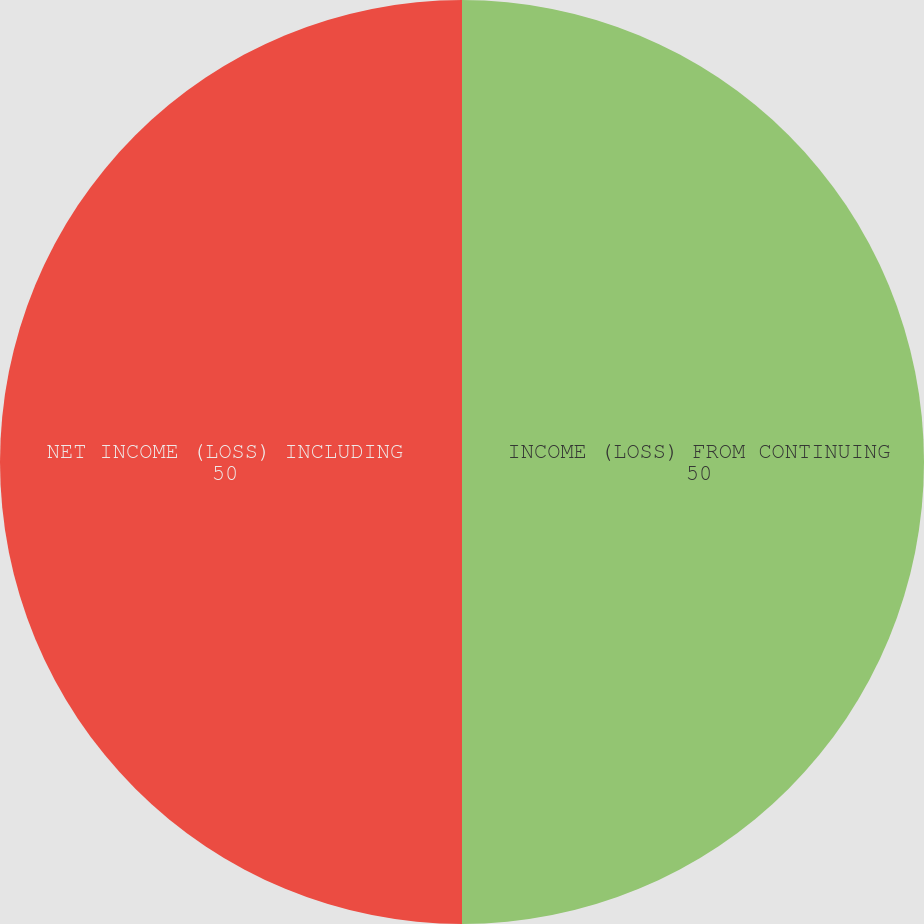Convert chart. <chart><loc_0><loc_0><loc_500><loc_500><pie_chart><fcel>INCOME (LOSS) FROM CONTINUING<fcel>NET INCOME (LOSS) INCLUDING<nl><fcel>50.0%<fcel>50.0%<nl></chart> 